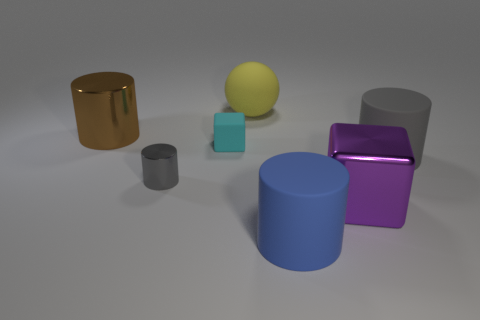Subtract all big cylinders. How many cylinders are left? 1 Subtract all brown spheres. How many gray cylinders are left? 2 Subtract all brown cylinders. How many cylinders are left? 3 Subtract 2 cylinders. How many cylinders are left? 2 Subtract all purple cylinders. Subtract all brown cubes. How many cylinders are left? 4 Subtract all balls. How many objects are left? 6 Add 1 metallic spheres. How many objects exist? 8 Subtract 0 blue balls. How many objects are left? 7 Subtract all large shiny cubes. Subtract all tiny rubber cubes. How many objects are left? 5 Add 1 purple metallic things. How many purple metallic things are left? 2 